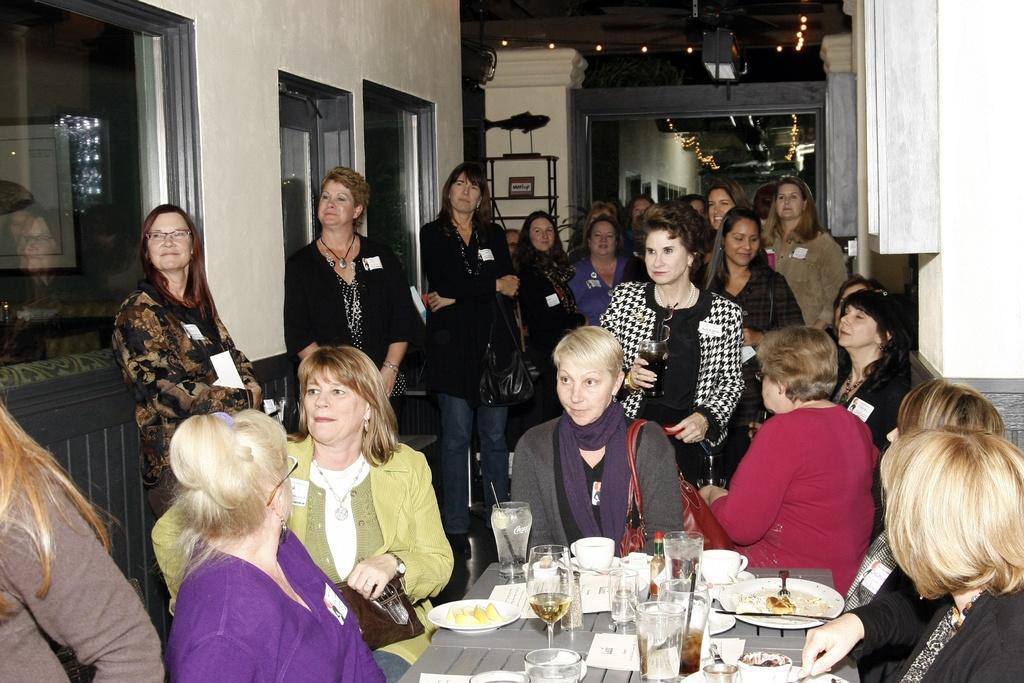Please provide a concise description of this image. In the image there are a lot of people who are women some of them are standing and some of them are standing and some of them are sitting the people who are sitting in front of them there is a table and upon the table there is some food and glasses and cups in the background there is a wall. 